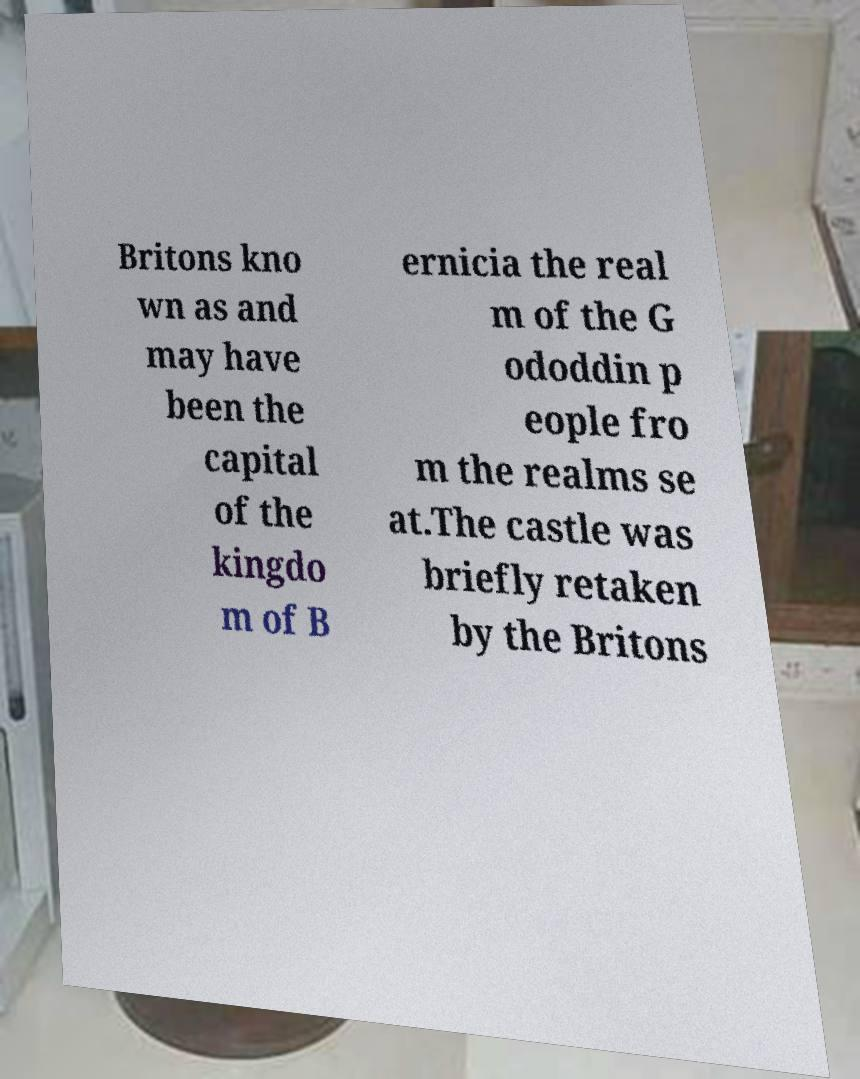Can you read and provide the text displayed in the image?This photo seems to have some interesting text. Can you extract and type it out for me? Britons kno wn as and may have been the capital of the kingdo m of B ernicia the real m of the G ododdin p eople fro m the realms se at.The castle was briefly retaken by the Britons 